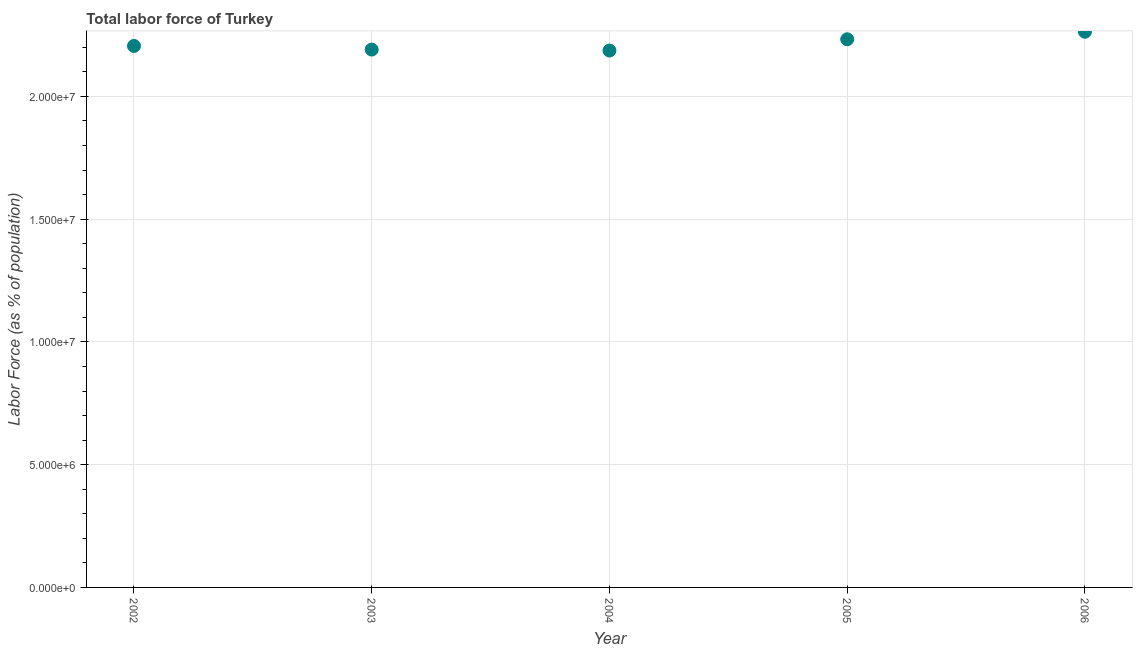What is the total labor force in 2004?
Give a very brief answer. 2.19e+07. Across all years, what is the maximum total labor force?
Make the answer very short. 2.26e+07. Across all years, what is the minimum total labor force?
Provide a short and direct response. 2.19e+07. In which year was the total labor force maximum?
Give a very brief answer. 2006. In which year was the total labor force minimum?
Offer a very short reply. 2004. What is the sum of the total labor force?
Give a very brief answer. 1.11e+08. What is the difference between the total labor force in 2004 and 2006?
Provide a succinct answer. -7.65e+05. What is the average total labor force per year?
Provide a succinct answer. 2.22e+07. What is the median total labor force?
Give a very brief answer. 2.21e+07. What is the ratio of the total labor force in 2004 to that in 2006?
Offer a terse response. 0.97. What is the difference between the highest and the second highest total labor force?
Offer a terse response. 3.06e+05. What is the difference between the highest and the lowest total labor force?
Offer a terse response. 7.65e+05. How many years are there in the graph?
Offer a terse response. 5. What is the difference between two consecutive major ticks on the Y-axis?
Keep it short and to the point. 5.00e+06. Does the graph contain grids?
Your answer should be compact. Yes. What is the title of the graph?
Your response must be concise. Total labor force of Turkey. What is the label or title of the Y-axis?
Give a very brief answer. Labor Force (as % of population). What is the Labor Force (as % of population) in 2002?
Give a very brief answer. 2.21e+07. What is the Labor Force (as % of population) in 2003?
Your answer should be very brief. 2.19e+07. What is the Labor Force (as % of population) in 2004?
Your answer should be compact. 2.19e+07. What is the Labor Force (as % of population) in 2005?
Give a very brief answer. 2.23e+07. What is the Labor Force (as % of population) in 2006?
Offer a very short reply. 2.26e+07. What is the difference between the Labor Force (as % of population) in 2002 and 2003?
Make the answer very short. 1.47e+05. What is the difference between the Labor Force (as % of population) in 2002 and 2004?
Give a very brief answer. 1.87e+05. What is the difference between the Labor Force (as % of population) in 2002 and 2005?
Offer a very short reply. -2.72e+05. What is the difference between the Labor Force (as % of population) in 2002 and 2006?
Provide a succinct answer. -5.78e+05. What is the difference between the Labor Force (as % of population) in 2003 and 2004?
Make the answer very short. 3.99e+04. What is the difference between the Labor Force (as % of population) in 2003 and 2005?
Offer a terse response. -4.19e+05. What is the difference between the Labor Force (as % of population) in 2003 and 2006?
Make the answer very short. -7.25e+05. What is the difference between the Labor Force (as % of population) in 2004 and 2005?
Your answer should be very brief. -4.59e+05. What is the difference between the Labor Force (as % of population) in 2004 and 2006?
Provide a short and direct response. -7.65e+05. What is the difference between the Labor Force (as % of population) in 2005 and 2006?
Ensure brevity in your answer.  -3.06e+05. What is the ratio of the Labor Force (as % of population) in 2002 to that in 2003?
Ensure brevity in your answer.  1.01. What is the ratio of the Labor Force (as % of population) in 2002 to that in 2005?
Your response must be concise. 0.99. What is the ratio of the Labor Force (as % of population) in 2002 to that in 2006?
Your answer should be compact. 0.97. What is the ratio of the Labor Force (as % of population) in 2003 to that in 2004?
Your answer should be compact. 1. What is the ratio of the Labor Force (as % of population) in 2003 to that in 2005?
Give a very brief answer. 0.98. What is the ratio of the Labor Force (as % of population) in 2003 to that in 2006?
Keep it short and to the point. 0.97. What is the ratio of the Labor Force (as % of population) in 2005 to that in 2006?
Offer a very short reply. 0.99. 